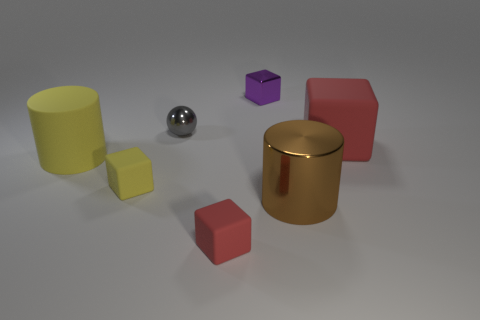Add 1 blue rubber cubes. How many objects exist? 8 Subtract all spheres. How many objects are left? 6 Add 5 red blocks. How many red blocks are left? 7 Add 6 tiny cyan rubber balls. How many tiny cyan rubber balls exist? 6 Subtract 0 cyan cubes. How many objects are left? 7 Subtract all large cylinders. Subtract all small blue shiny spheres. How many objects are left? 5 